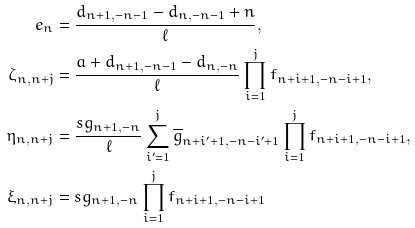Convert formula to latex. <formula><loc_0><loc_0><loc_500><loc_500>e _ { n } & = \frac { d _ { n + 1 , - n - 1 } - d _ { n , - n - 1 } + n } { \ell } , \\ \zeta _ { n , n + j } & = \frac { a + d _ { n + 1 , - n - 1 } - d _ { n , - n } } { \ell } \prod _ { i = 1 } ^ { j } f _ { n + i + 1 , - n - i + 1 } , \\ \eta _ { n , n + j } & = \frac { s g _ { n + 1 , - n } } { \ell } \sum _ { i ^ { \prime } = 1 } ^ { j } \overline { g } _ { n + i ^ { \prime } + 1 , - n - i ^ { \prime } + 1 } \prod _ { i = 1 } ^ { j } f _ { n + i + 1 , - n - i + 1 } , \\ \xi _ { n , n + j } & = s g _ { n + 1 , - n } \prod _ { i = 1 } ^ { j } f _ { n + i + 1 , - n - i + 1 }</formula> 